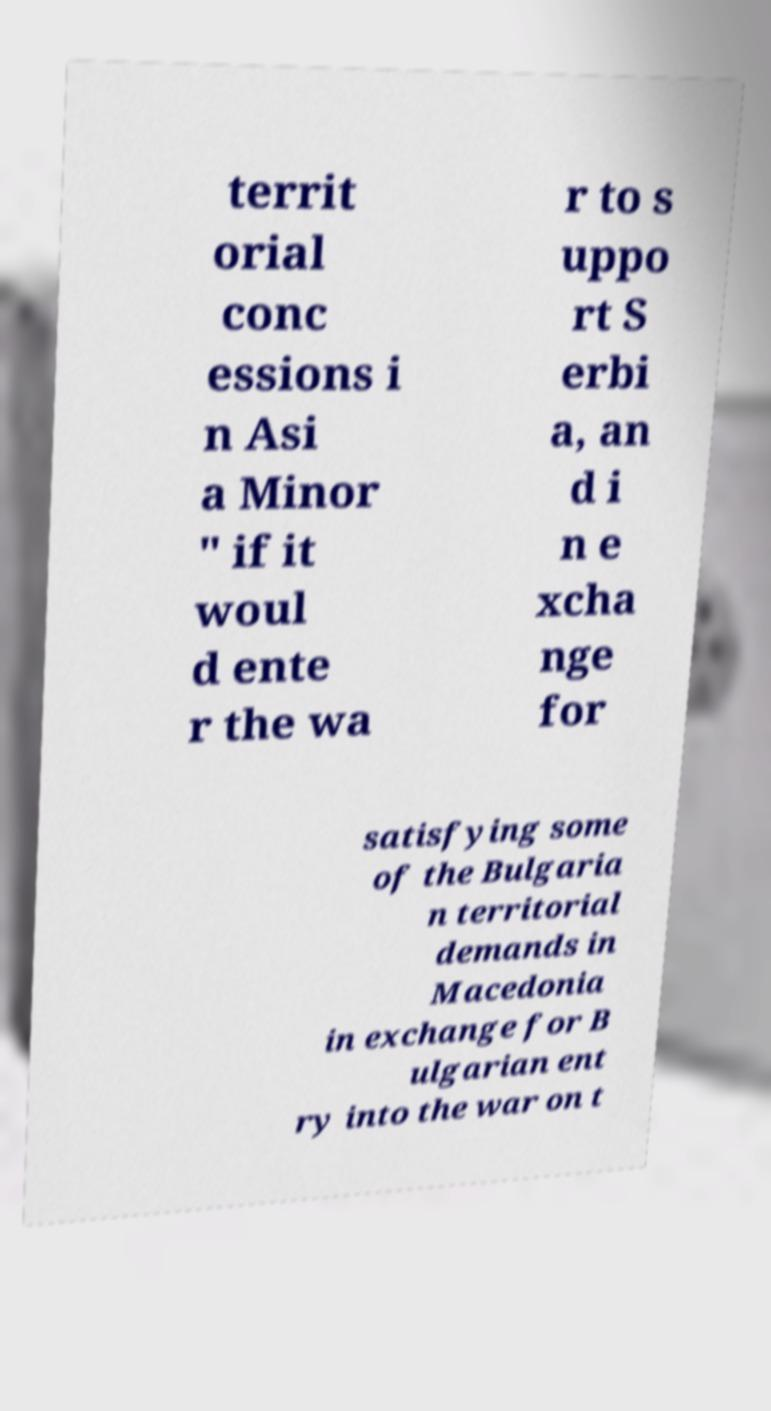Can you accurately transcribe the text from the provided image for me? territ orial conc essions i n Asi a Minor " if it woul d ente r the wa r to s uppo rt S erbi a, an d i n e xcha nge for satisfying some of the Bulgaria n territorial demands in Macedonia in exchange for B ulgarian ent ry into the war on t 